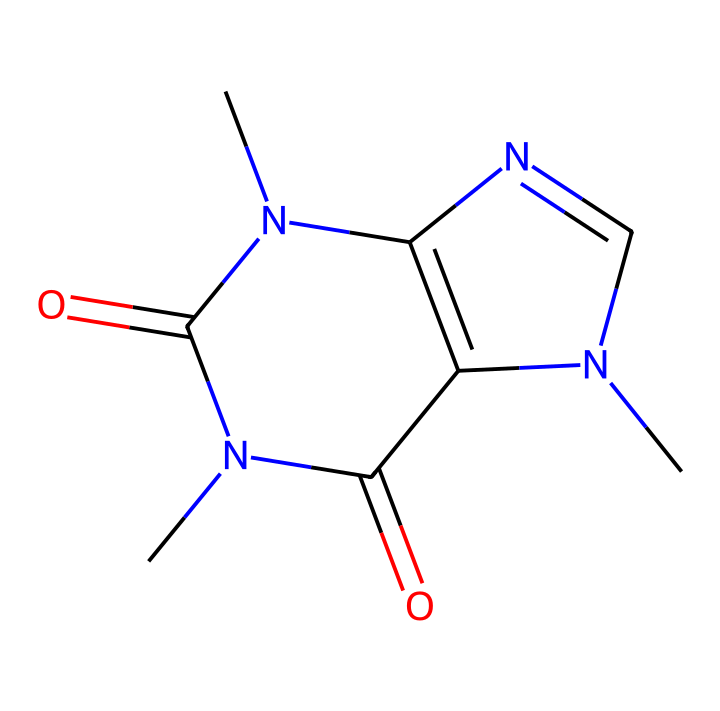What is the molecular formula of caffeine? To determine the molecular formula, we need to count the number of each type of atom in the structure represented by the SMILES. Caffeine contains 8 carbon (C) atoms, 10 hydrogen (H) atoms, 4 nitrogen (N) atoms, and 2 oxygen (O) atoms, leading to the formula C8H10N4O2.
Answer: C8H10N4O2 How many nitrogen atoms are present in caffeine? By observing the structure or the SMILES representation, we can identify that there are four nitrogen (N) atoms present in caffeine.
Answer: 4 What type of compound is caffeine classified as? Caffeine is categorized as an alkaloid due to its nitrogen-containing structure and its physiological effects. Alkaloids are known for their biological activity and presence in plants.
Answer: alkaloid Which functional groups are present in caffeine? In the structure of caffeine, you can identify the presence of carbonyl (C=O) and amine (NH) functional groups. The carbonyl groups contribute to the reactivity of the molecule, while the amine groups are indicative of its classification as an alkaloid.
Answer: carbonyl and amine How many rings are present in the structure of caffeine? The structure includes two fused rings, which can be confirmed by examining the connections and cyclical nature of the atoms organized in a circular form. This is a characteristic feature of many alkaloids.
Answer: 2 What aspect of caffeine's structure contributes to its stimulant properties? The presence of nitrogen atoms contributes to the stimulant properties of caffeine, as they are key elements in many neurotransmitters. Specifically, the arrangement and bonding of these nitrogen atoms play a crucial role in how caffeine interacts with the brain.
Answer: nitrogen atoms 